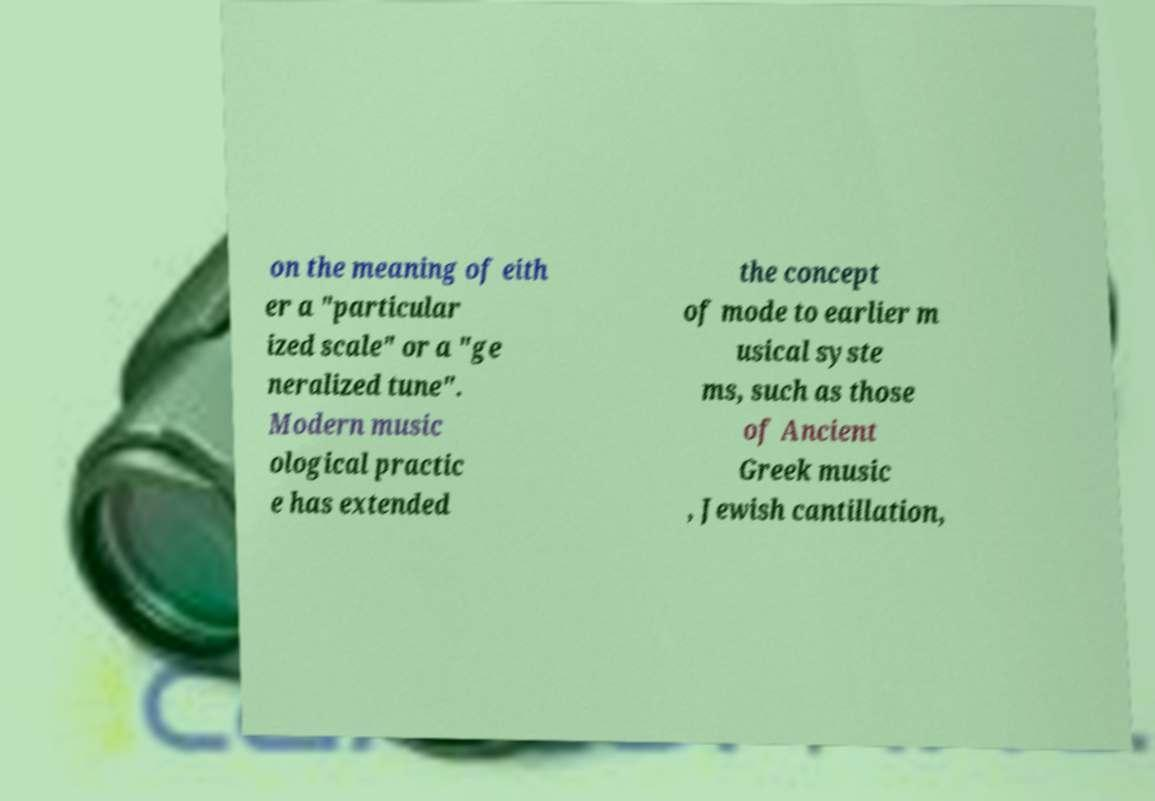Can you accurately transcribe the text from the provided image for me? on the meaning of eith er a "particular ized scale" or a "ge neralized tune". Modern music ological practic e has extended the concept of mode to earlier m usical syste ms, such as those of Ancient Greek music , Jewish cantillation, 